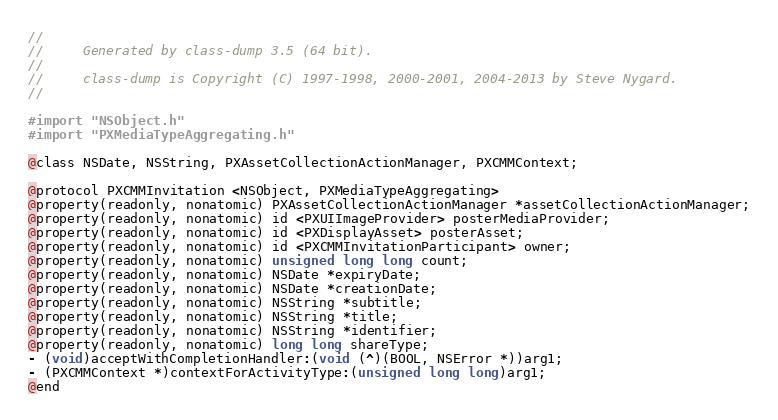Convert code to text. <code><loc_0><loc_0><loc_500><loc_500><_C_>//
//     Generated by class-dump 3.5 (64 bit).
//
//     class-dump is Copyright (C) 1997-1998, 2000-2001, 2004-2013 by Steve Nygard.
//

#import "NSObject.h"
#import "PXMediaTypeAggregating.h"

@class NSDate, NSString, PXAssetCollectionActionManager, PXCMMContext;

@protocol PXCMMInvitation <NSObject, PXMediaTypeAggregating>
@property(readonly, nonatomic) PXAssetCollectionActionManager *assetCollectionActionManager;
@property(readonly, nonatomic) id <PXUIImageProvider> posterMediaProvider;
@property(readonly, nonatomic) id <PXDisplayAsset> posterAsset;
@property(readonly, nonatomic) id <PXCMMInvitationParticipant> owner;
@property(readonly, nonatomic) unsigned long long count;
@property(readonly, nonatomic) NSDate *expiryDate;
@property(readonly, nonatomic) NSDate *creationDate;
@property(readonly, nonatomic) NSString *subtitle;
@property(readonly, nonatomic) NSString *title;
@property(readonly, nonatomic) NSString *identifier;
@property(readonly, nonatomic) long long shareType;
- (void)acceptWithCompletionHandler:(void (^)(BOOL, NSError *))arg1;
- (PXCMMContext *)contextForActivityType:(unsigned long long)arg1;
@end

</code> 